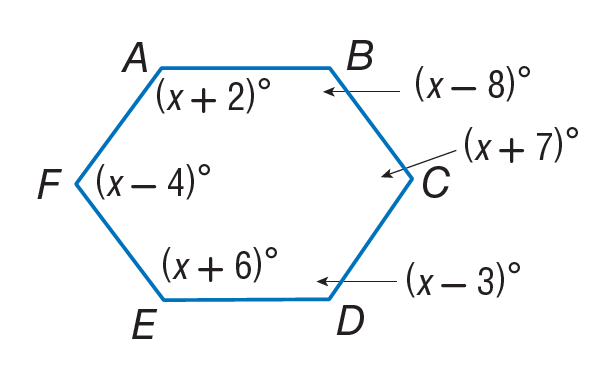Answer the mathemtical geometry problem and directly provide the correct option letter.
Question: Find m \angle C.
Choices: A: 112 B: 116 C: 117 D: 127 D 